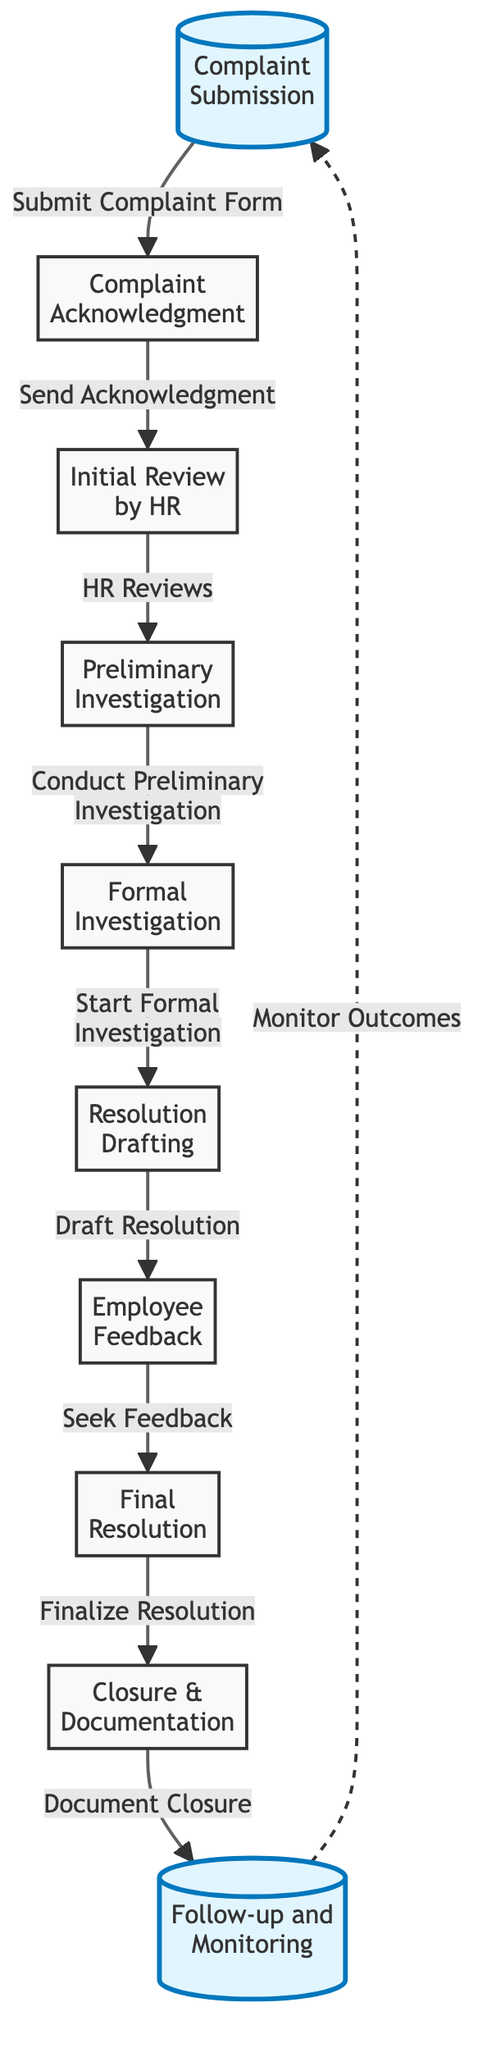What is the first step in the workflow? The diagram identifies "Complaint Submission" as the first step. It is indicated at the beginning of the flowchart, showcasing that the process starts with employees submitting their complaints.
Answer: Complaint Submission How many steps are there in total? By counting the nodes in the flowchart, we find there are ten distinct steps involved in the workflow. Each step is represented as a separate block in the diagram, contributing to the total.
Answer: 10 Which step comes after "Initial Review by HR"? Following the "Initial Review by HR" step, the next step is the "Preliminary Investigation." This is shown by the directional arrow leading from the HR review to the investigation phase.
Answer: Preliminary Investigation What action occurs after "Seek Feedback"? After the "Seek Feedback" action, the flowchart indicates the next step is "Finalize Resolution." This relationship is direct and is represented by an arrow leading from the feedback step to the resolution phase.
Answer: Finalize Resolution What is the purpose of the "Follow-up and Monitoring" step? The "Follow-up and Monitoring" step ensures that the outcomes of the resolution are tracked and assessed for effectiveness. The workflow shows that this monitoring leads back to initial complaints, indicating a continuous improvement cycle.
Answer: Monitor Outcomes In total, how many formal investigation steps are indicated? The flowchart includes just one formal investigation step, as indicated by the single node labeled "Formal Investigation" in the sequence of events.
Answer: 1 What is the last action described in the workflow? The last action in the workflow is "Document Closure," marking the end of the resolution process. It is positioned just before the follow-up and monitoring step.
Answer: Document Closure Which step involves employee input? The step "Employee Feedback" directly involves employee input, as it requires seeking the employee's opinion on the drafted resolution before finalizing it. This step is critical in ensuring that their concerns are addressed accordingly.
Answer: Employee Feedback What is the relationship between "Final Resolution" and "Follow-up and Monitoring"? The relationship is sequential; after reaching the "Final Resolution," the process moves into "Follow-up and Monitoring," indicating a direct progression from resolution to reviewing the resolution's effectiveness.
Answer: Sequential 